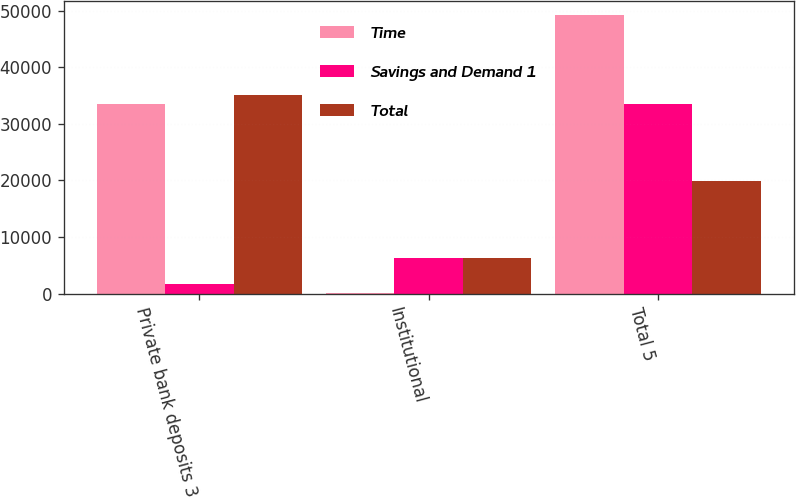Convert chart to OTSL. <chart><loc_0><loc_0><loc_500><loc_500><stacked_bar_chart><ecel><fcel>Private bank deposits 3<fcel>Institutional<fcel>Total 5<nl><fcel>Time<fcel>33590<fcel>12<fcel>49293<nl><fcel>Savings and Demand 1<fcel>1609<fcel>6198<fcel>33587<nl><fcel>Total<fcel>35199<fcel>6210<fcel>19898.5<nl></chart> 